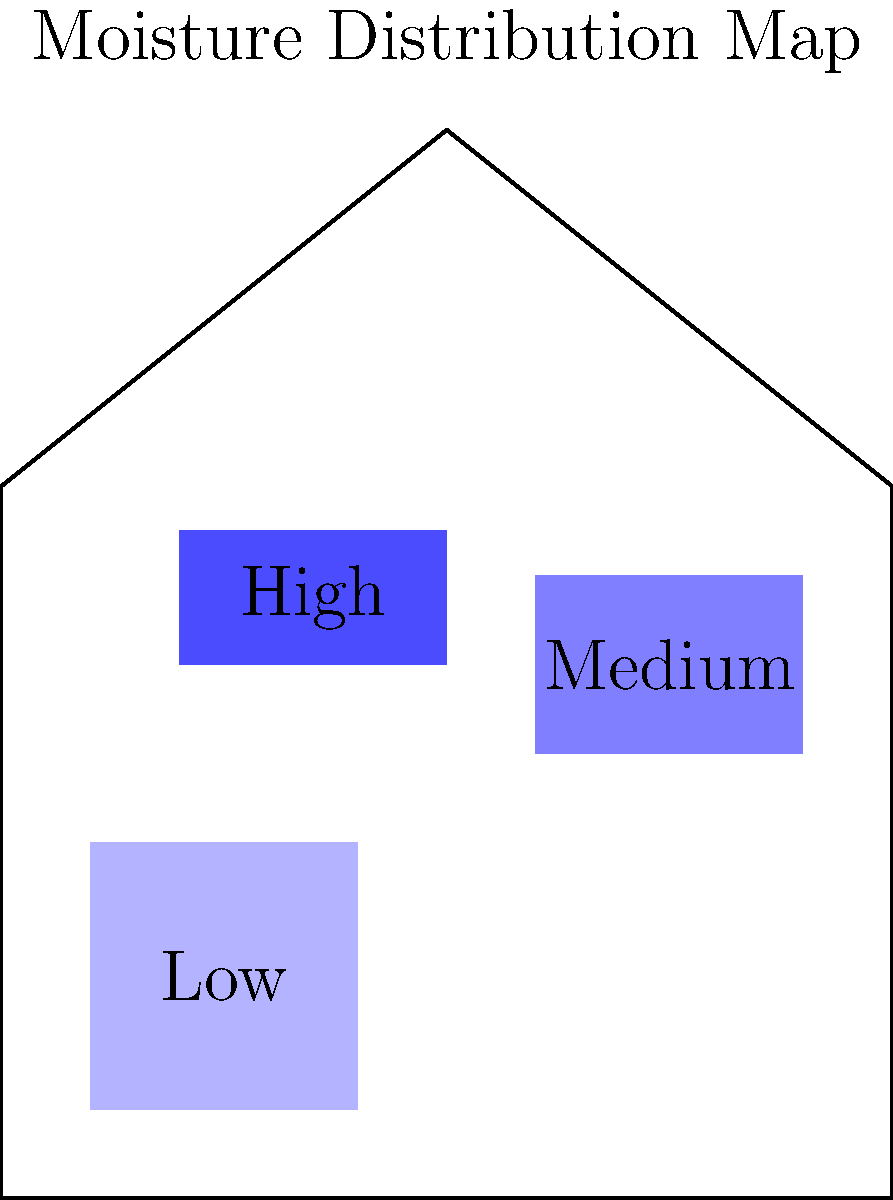Based on the moisture distribution map of a house, which area is most likely to develop mold growth and should be prioritized for remediation? To determine the area most likely to develop mold growth, we need to analyze the moisture distribution map:

1. Identify moisture levels:
   - Light blue area: Low moisture
   - Medium blue area: Medium moisture
   - Dark blue area: High moisture

2. Understand mold growth conditions:
   - Mold thrives in areas with high moisture content
   - Higher moisture levels increase the risk of mold growth

3. Analyze the map:
   - The dark blue area in the upper left portion of the house indicates the highest moisture level
   - This area has the greatest potential for mold growth due to excessive moisture

4. Consider remediation priority:
   - Areas with the highest moisture content should be addressed first to prevent mold growth
   - The dark blue area requires immediate attention and remediation efforts

5. Additional considerations:
   - While other areas show moisture presence, they are at lower risk compared to the dark blue area
   - However, all areas with elevated moisture should be monitored and addressed to prevent future issues

Therefore, the area with the highest moisture content (dark blue) should be prioritized for remediation to prevent mold growth.
Answer: The dark blue (high moisture) area in the upper left portion of the house 